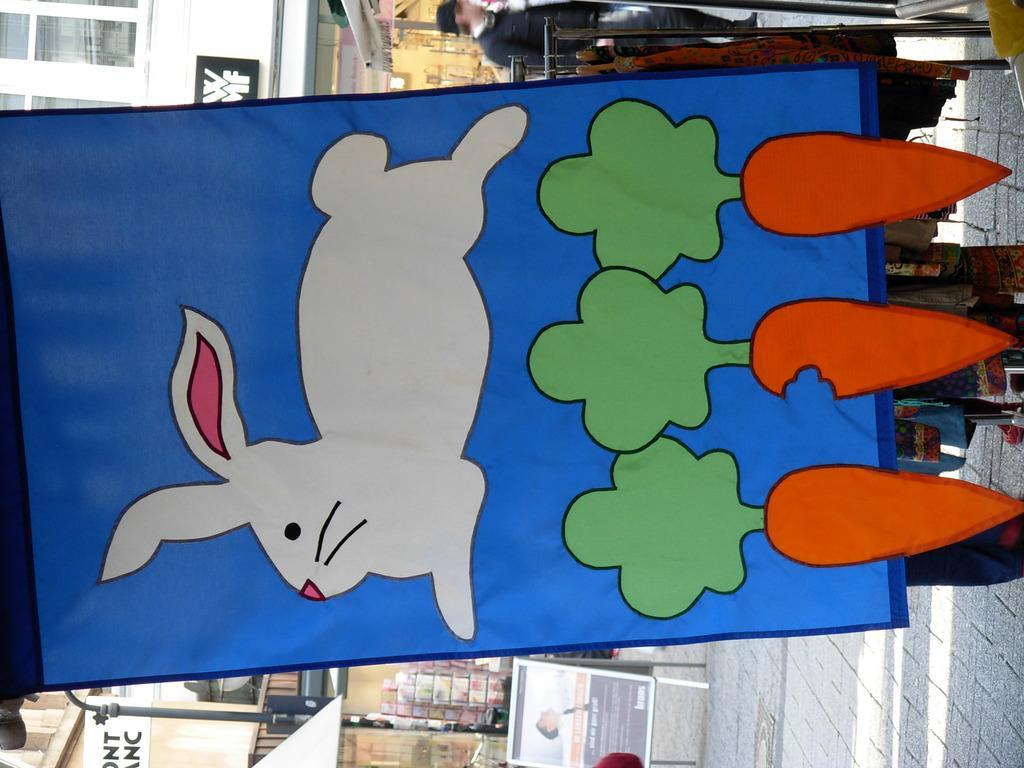Describe this image in one or two sentences. In this image we can see the pictures of rabbit and carrots on a banner. On the backside we can see a building with windows, pole and a person standing on the right side. 